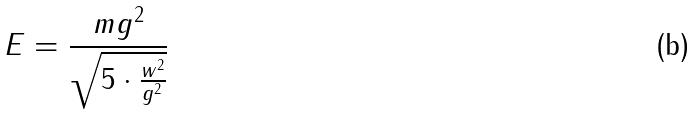<formula> <loc_0><loc_0><loc_500><loc_500>E = \frac { m g ^ { 2 } } { \sqrt { 5 \cdot \frac { w ^ { 2 } } { g ^ { 2 } } } }</formula> 